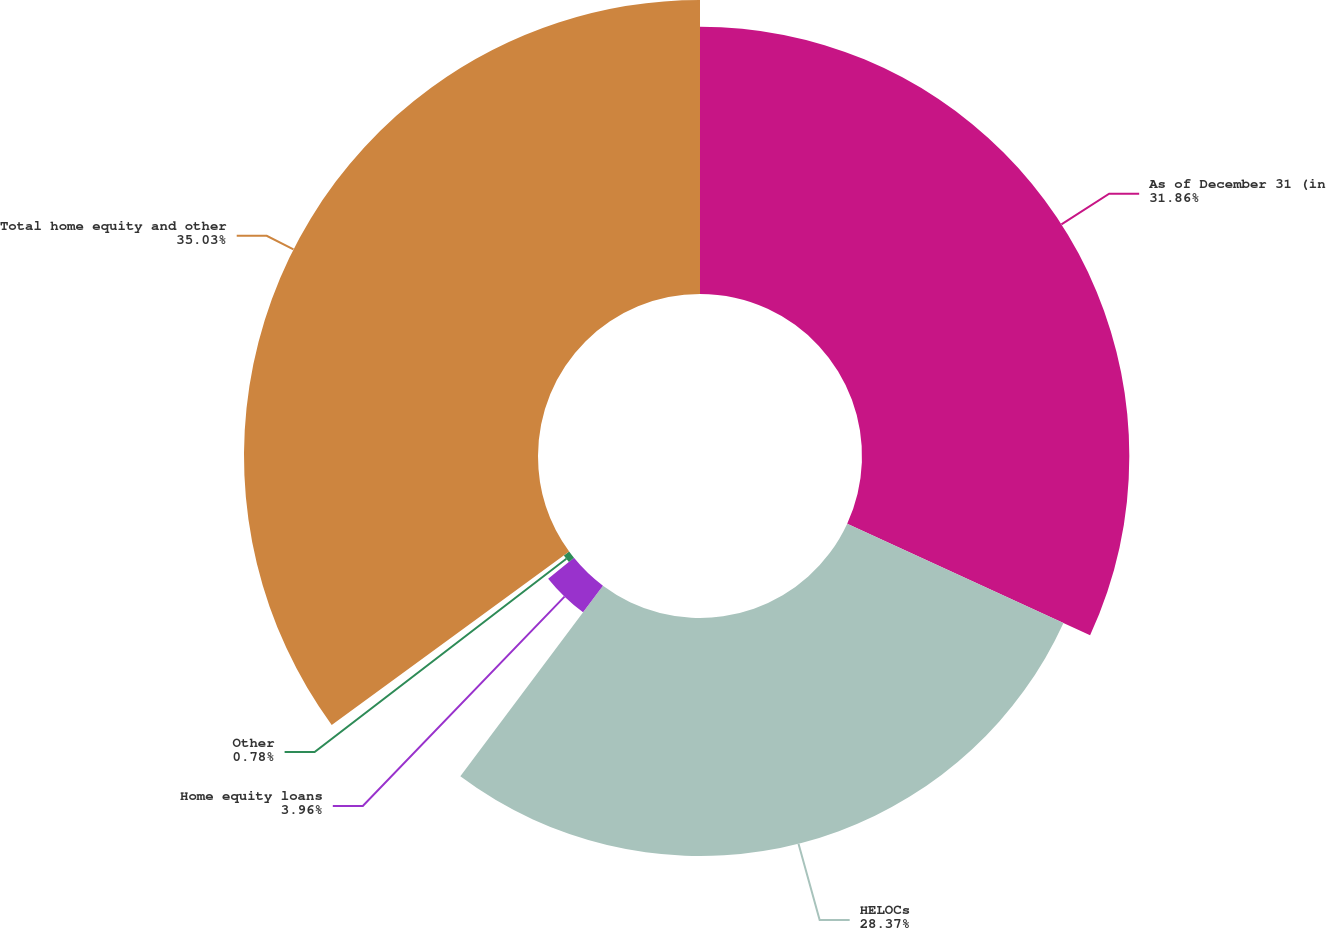Convert chart. <chart><loc_0><loc_0><loc_500><loc_500><pie_chart><fcel>As of December 31 (in<fcel>HELOCs<fcel>Home equity loans<fcel>Other<fcel>Total home equity and other<nl><fcel>31.86%<fcel>28.37%<fcel>3.96%<fcel>0.78%<fcel>35.04%<nl></chart> 